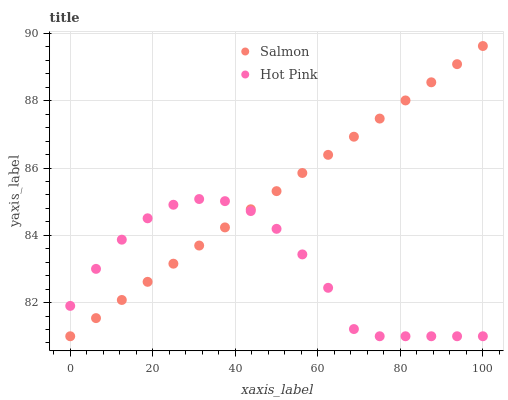Does Hot Pink have the minimum area under the curve?
Answer yes or no. Yes. Does Salmon have the maximum area under the curve?
Answer yes or no. Yes. Does Salmon have the minimum area under the curve?
Answer yes or no. No. Is Salmon the smoothest?
Answer yes or no. Yes. Is Hot Pink the roughest?
Answer yes or no. Yes. Is Salmon the roughest?
Answer yes or no. No. Does Hot Pink have the lowest value?
Answer yes or no. Yes. Does Salmon have the highest value?
Answer yes or no. Yes. Does Hot Pink intersect Salmon?
Answer yes or no. Yes. Is Hot Pink less than Salmon?
Answer yes or no. No. Is Hot Pink greater than Salmon?
Answer yes or no. No. 